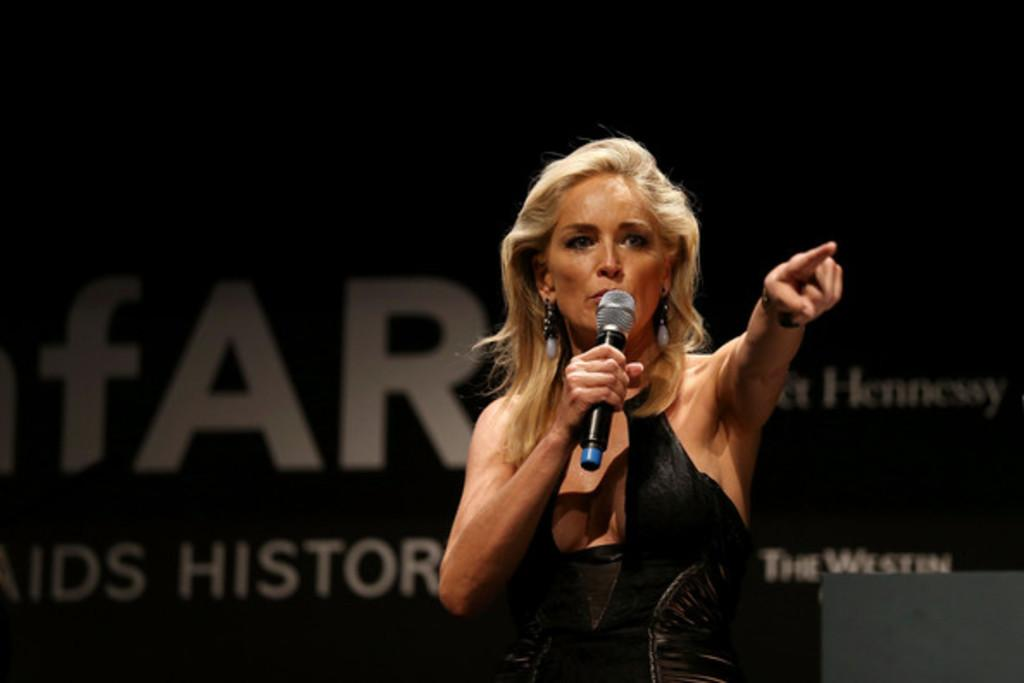Who is the main subject in the image? There is a woman in the image. What is the woman holding in her hand? The woman is holding a microphone in her hand. What is the woman doing in the image? The woman is talking. What can be seen in the background of the image? There is a banner in the background of the image, and the background is dark. What object is in front of the woman? There is a laptop in front of the woman. How many clovers are on the woman's shirt in the image? There are no clovers visible on the woman's shirt in the image. What type of mask is the woman wearing in the image? The woman is not wearing a mask in the image. 